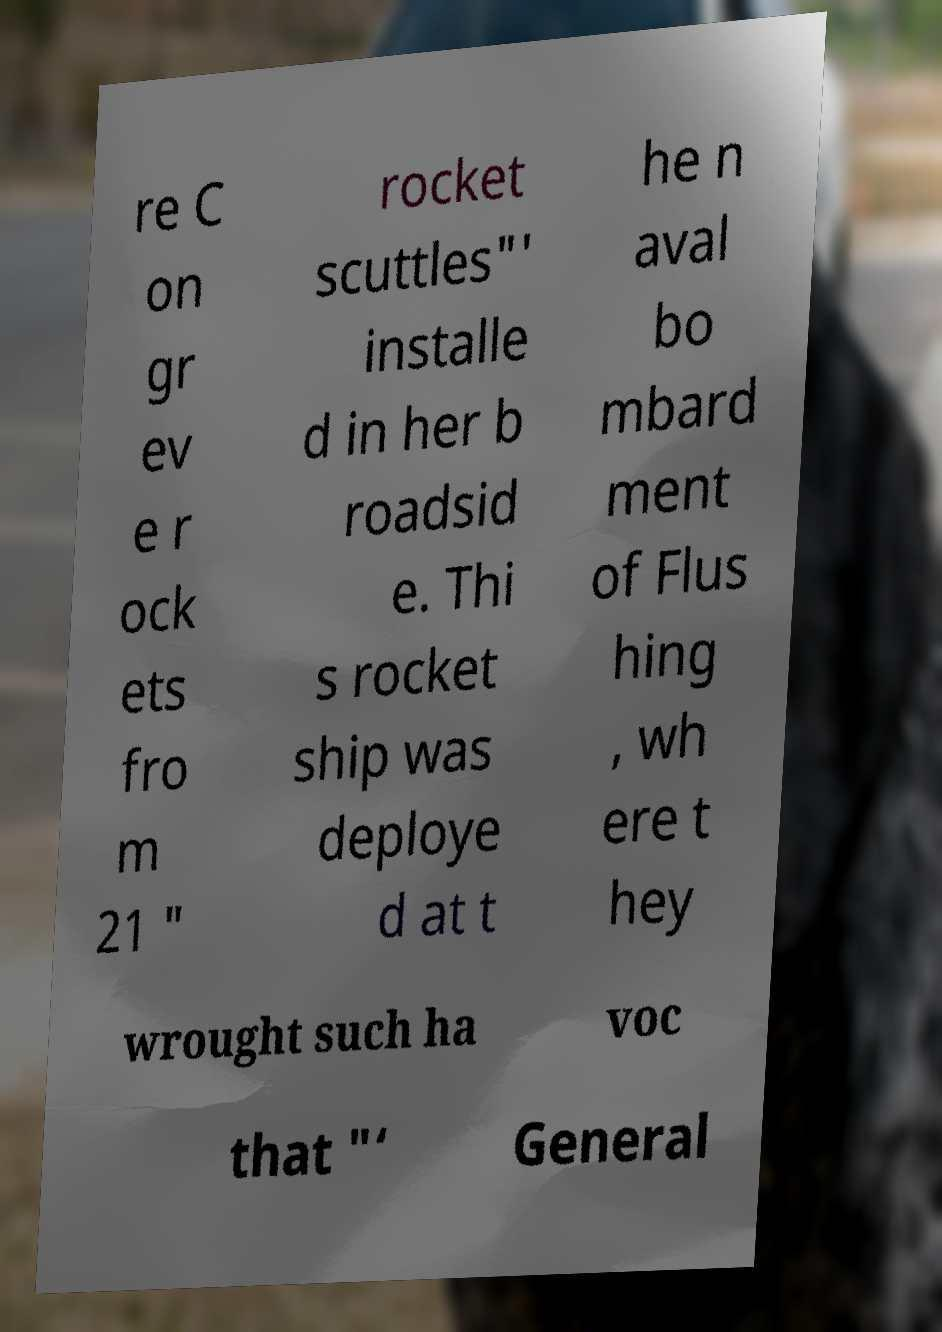Please identify and transcribe the text found in this image. re C on gr ev e r ock ets fro m 21 " rocket scuttles"' installe d in her b roadsid e. Thi s rocket ship was deploye d at t he n aval bo mbard ment of Flus hing , wh ere t hey wrought such ha voc that "‘ General 